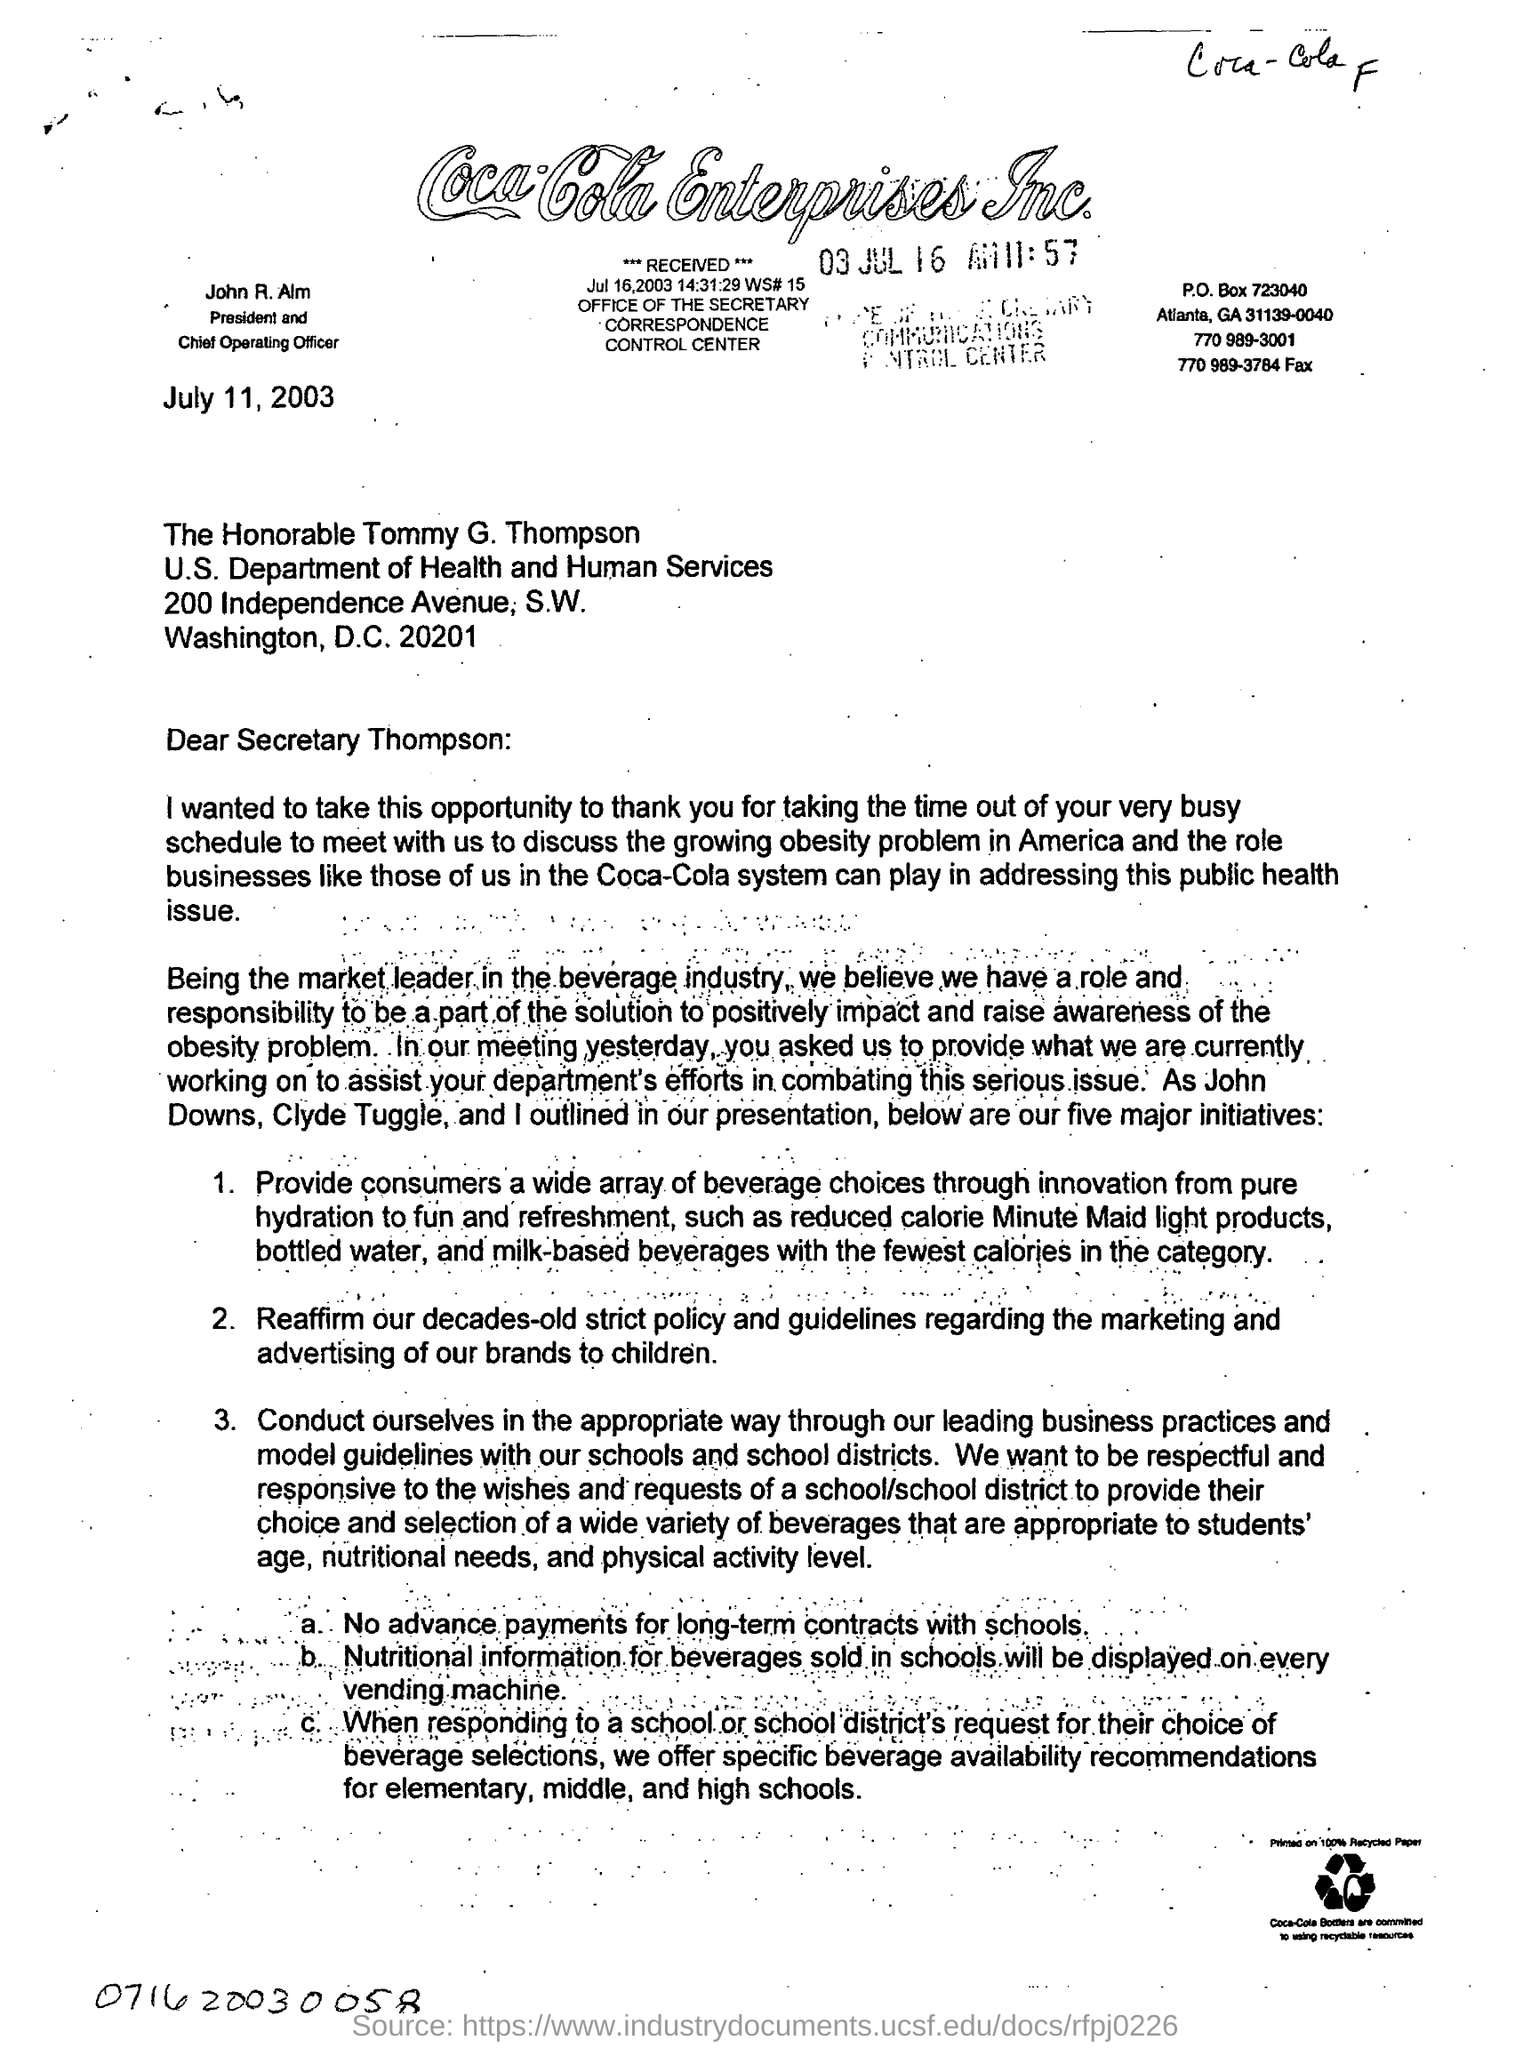Mention a couple of crucial points in this snapshot. We reaffirm our long-standing policy and guidelines regarding the marketing and advertising of our brands to children, as highlighted in the second point of our letter. John R. Alm is the president and chief operating officer. 